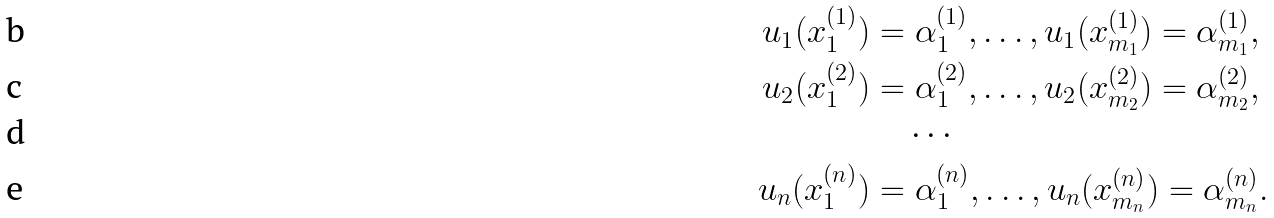Convert formula to latex. <formula><loc_0><loc_0><loc_500><loc_500>u _ { 1 } ( x _ { 1 } ^ { ( 1 ) } ) & = \alpha _ { 1 } ^ { ( 1 ) } , \dots , u _ { 1 } ( x _ { m _ { 1 } } ^ { ( 1 ) } ) = \alpha _ { m _ { 1 } } ^ { ( 1 ) } , \\ u _ { 2 } ( x _ { 1 } ^ { ( 2 ) } ) & = \alpha _ { 1 } ^ { ( 2 ) } , \dots , u _ { 2 } ( x _ { m _ { 2 } } ^ { ( 2 ) } ) = \alpha _ { m _ { 2 } } ^ { ( 2 ) } , \\ & \quad \cdots \\ u _ { n } ( x _ { 1 } ^ { ( n ) } ) & = \alpha _ { 1 } ^ { ( n ) } , \dots , u _ { n } ( x _ { m _ { n } } ^ { ( n ) } ) = \alpha _ { m _ { n } } ^ { ( n ) } .</formula> 